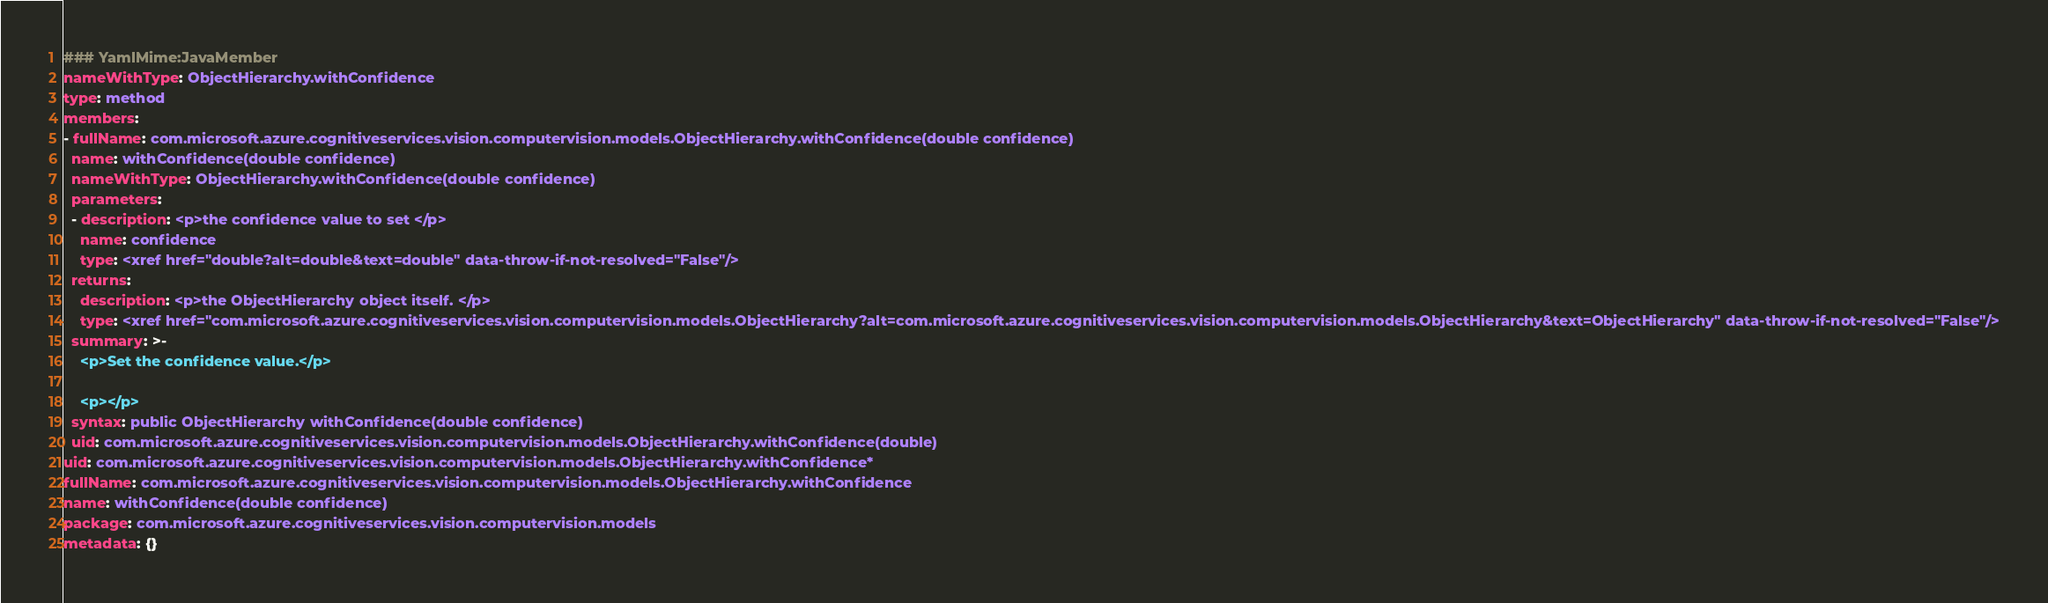<code> <loc_0><loc_0><loc_500><loc_500><_YAML_>### YamlMime:JavaMember
nameWithType: ObjectHierarchy.withConfidence
type: method
members:
- fullName: com.microsoft.azure.cognitiveservices.vision.computervision.models.ObjectHierarchy.withConfidence(double confidence)
  name: withConfidence(double confidence)
  nameWithType: ObjectHierarchy.withConfidence(double confidence)
  parameters:
  - description: <p>the confidence value to set </p>
    name: confidence
    type: <xref href="double?alt=double&text=double" data-throw-if-not-resolved="False"/>
  returns:
    description: <p>the ObjectHierarchy object itself. </p>
    type: <xref href="com.microsoft.azure.cognitiveservices.vision.computervision.models.ObjectHierarchy?alt=com.microsoft.azure.cognitiveservices.vision.computervision.models.ObjectHierarchy&text=ObjectHierarchy" data-throw-if-not-resolved="False"/>
  summary: >-
    <p>Set the confidence value.</p>

    <p></p>
  syntax: public ObjectHierarchy withConfidence(double confidence)
  uid: com.microsoft.azure.cognitiveservices.vision.computervision.models.ObjectHierarchy.withConfidence(double)
uid: com.microsoft.azure.cognitiveservices.vision.computervision.models.ObjectHierarchy.withConfidence*
fullName: com.microsoft.azure.cognitiveservices.vision.computervision.models.ObjectHierarchy.withConfidence
name: withConfidence(double confidence)
package: com.microsoft.azure.cognitiveservices.vision.computervision.models
metadata: {}
</code> 